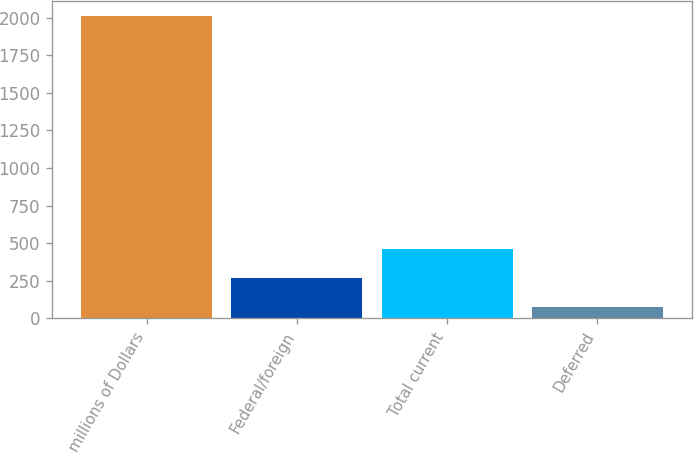Convert chart to OTSL. <chart><loc_0><loc_0><loc_500><loc_500><bar_chart><fcel>millions of Dollars<fcel>Federal/foreign<fcel>Total current<fcel>Deferred<nl><fcel>2008<fcel>268.21<fcel>461.52<fcel>74.9<nl></chart> 